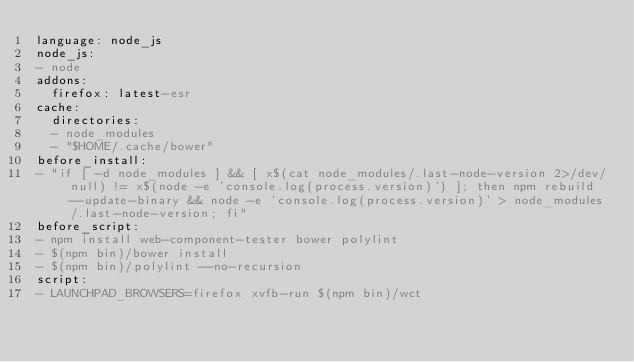Convert code to text. <code><loc_0><loc_0><loc_500><loc_500><_YAML_>language: node_js
node_js:
- node
addons:
  firefox: latest-esr
cache:
  directories:
  - node_modules
  - "$HOME/.cache/bower"
before_install:
- "if [ -d node_modules ] && [ x$(cat node_modules/.last-node-version 2>/dev/null) != x$(node -e 'console.log(process.version)') ]; then npm rebuild --update-binary && node -e 'console.log(process.version)' > node_modules/.last-node-version; fi"
before_script:
- npm install web-component-tester bower polylint
- $(npm bin)/bower install
- $(npm bin)/polylint --no-recursion
script:
- LAUNCHPAD_BROWSERS=firefox xvfb-run $(npm bin)/wct
</code> 